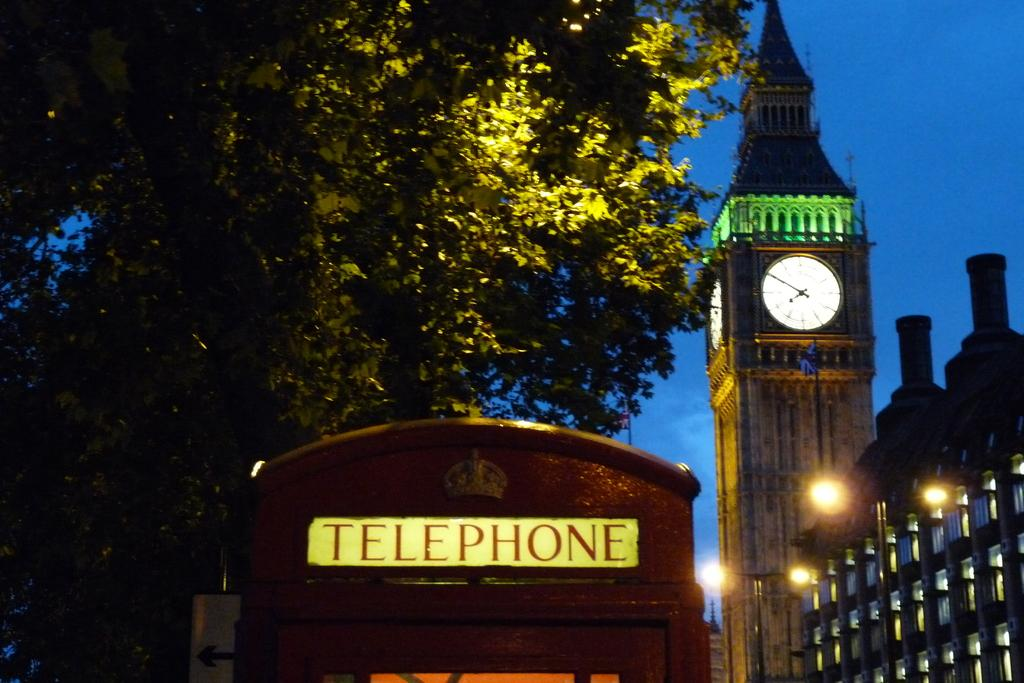<image>
Offer a succinct explanation of the picture presented. Red booth which says Telephone on the top. 